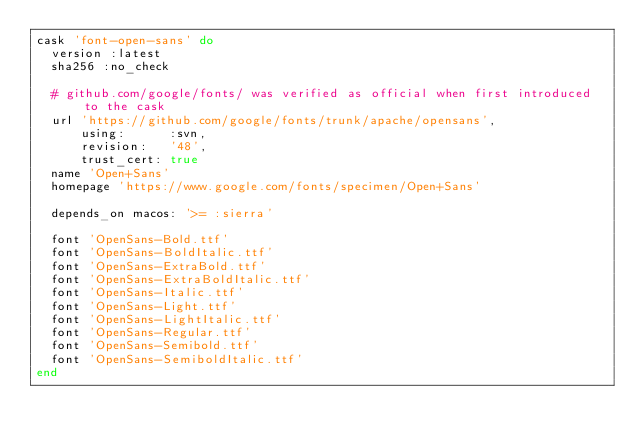<code> <loc_0><loc_0><loc_500><loc_500><_Ruby_>cask 'font-open-sans' do
  version :latest
  sha256 :no_check

  # github.com/google/fonts/ was verified as official when first introduced to the cask
  url 'https://github.com/google/fonts/trunk/apache/opensans',
      using:      :svn,
      revision:   '48',
      trust_cert: true
  name 'Open+Sans'
  homepage 'https://www.google.com/fonts/specimen/Open+Sans'

  depends_on macos: '>= :sierra'

  font 'OpenSans-Bold.ttf'
  font 'OpenSans-BoldItalic.ttf'
  font 'OpenSans-ExtraBold.ttf'
  font 'OpenSans-ExtraBoldItalic.ttf'
  font 'OpenSans-Italic.ttf'
  font 'OpenSans-Light.ttf'
  font 'OpenSans-LightItalic.ttf'
  font 'OpenSans-Regular.ttf'
  font 'OpenSans-Semibold.ttf'
  font 'OpenSans-SemiboldItalic.ttf'
end
</code> 